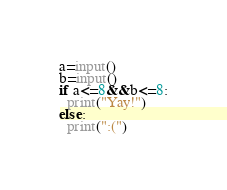Convert code to text. <code><loc_0><loc_0><loc_500><loc_500><_Python_>a=input()
b=input()
if a<=8&&b<=8:
  print("Yay!")
else:
  print(":(")
</code> 